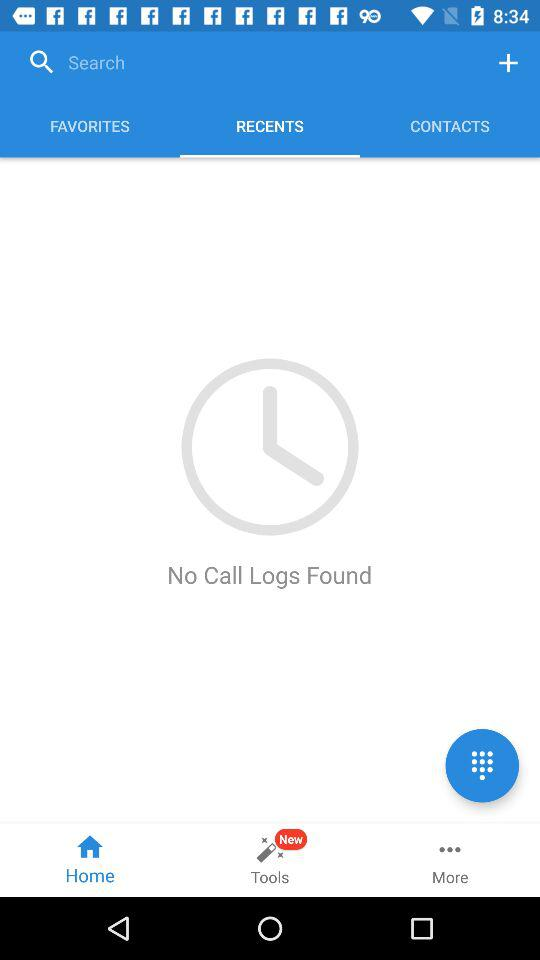Which tab has been selected? The tabs that have been selected are "RECENTS" and "Home". 